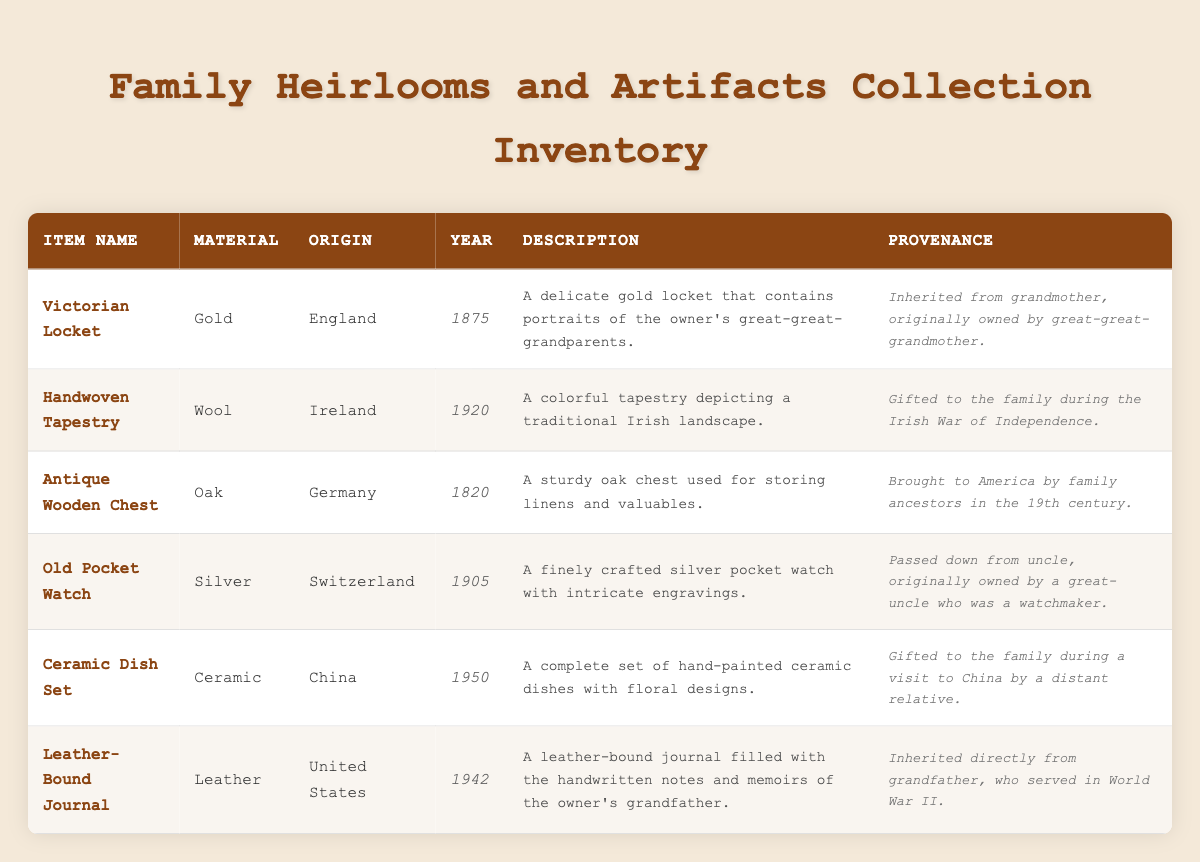What is the material of the Victorian Locket? The material is directly listed in the table under the "Material" column corresponding to the "Victorian Locket" item. It states that the Victorian Locket is made of Gold.
Answer: Gold Which item was originally owned by a great-uncle who was a watchmaker? By examining the provenance information in the table, we find that the "Old Pocket Watch" has a provenance that says it was originally owned by a great-uncle who was a watchmaker.
Answer: Old Pocket Watch How many items in the collection have an origin in Europe? To determine this, we can manually count the origins listed as countries in Europe from the table. The relevant items are: Victorian Locket (England), Handwoven Tapestry (Ireland), Antique Wooden Chest (Germany), and Old Pocket Watch (Switzerland). That's a total of 4 items.
Answer: 4 Is the Ceramic Dish Set older than the Leather-Bound Journal? The table clearly states the year of origin for each item. The Ceramic Dish Set was created in 1950, while the Leather-Bound Journal was created in 1942. Since 1942 is earlier than 1950, the answer is no.
Answer: No What is the average year of origin for the items in the collection? To find the average year of origin, I will sum the years: 1875 + 1920 + 1820 + 1905 + 1950 + 1942 = 11512. There are 6 items, so I divide the total by 6: 11512 / 6 = 1918.67. Hence, the average year of origin is approximately 1919.
Answer: 1919 Which two items have a description that includes the word "gifted"? We can scan through the descriptions of each item in the table. The items "Handwoven Tapestry" and "Ceramic Dish Set" both have descriptions that include the word "gifted".
Answer: Handwoven Tapestry, Ceramic Dish Set Was the Antique Wooden Chest brought to America during the 19th century? Looking at the provenance details for the Antique Wooden Chest, it specifically states that it was brought to America by family ancestors in the 19th century. Therefore, the statement is true.
Answer: Yes How many items were gifted to the family, and what are they? I will look at the provenance information for the items in the table. The "Handwoven Tapestry" and the "Ceramic Dish Set" are both noted as being gifted. Thus, there are two items in total.
Answer: 2 items: Handwoven Tapestry, Ceramic Dish Set 